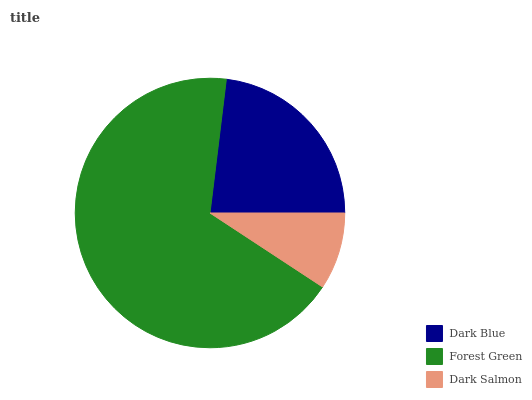Is Dark Salmon the minimum?
Answer yes or no. Yes. Is Forest Green the maximum?
Answer yes or no. Yes. Is Forest Green the minimum?
Answer yes or no. No. Is Dark Salmon the maximum?
Answer yes or no. No. Is Forest Green greater than Dark Salmon?
Answer yes or no. Yes. Is Dark Salmon less than Forest Green?
Answer yes or no. Yes. Is Dark Salmon greater than Forest Green?
Answer yes or no. No. Is Forest Green less than Dark Salmon?
Answer yes or no. No. Is Dark Blue the high median?
Answer yes or no. Yes. Is Dark Blue the low median?
Answer yes or no. Yes. Is Dark Salmon the high median?
Answer yes or no. No. Is Dark Salmon the low median?
Answer yes or no. No. 